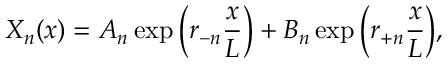<formula> <loc_0><loc_0><loc_500><loc_500>X _ { n } ( x ) = A _ { n } \exp { \left ( r _ { - n } \frac { x } { L } \right ) } + B _ { n } \exp { \left ( r _ { + n } \frac { x } { L } \right ) } ,</formula> 